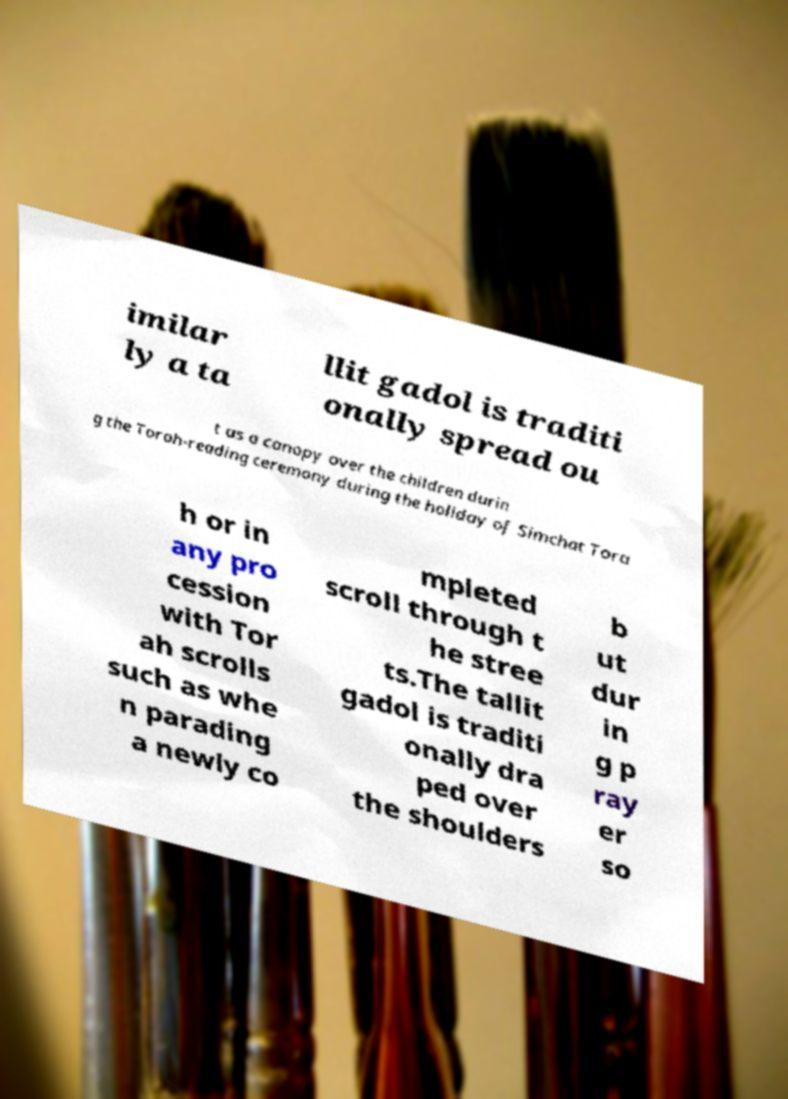What messages or text are displayed in this image? I need them in a readable, typed format. imilar ly a ta llit gadol is traditi onally spread ou t as a canopy over the children durin g the Torah-reading ceremony during the holiday of Simchat Tora h or in any pro cession with Tor ah scrolls such as whe n parading a newly co mpleted scroll through t he stree ts.The tallit gadol is traditi onally dra ped over the shoulders b ut dur in g p ray er so 